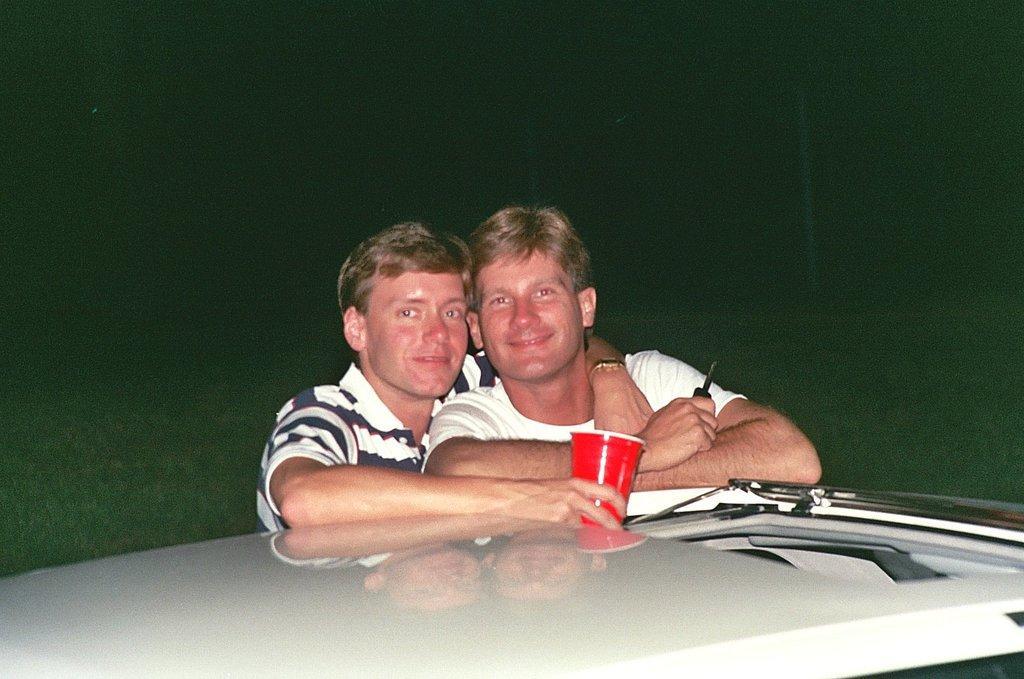Could you give a brief overview of what you see in this image? In this picture there are two men smiling and this man holding a glass, in front of these two men we can see white platform. In the background of the image it is dark. 